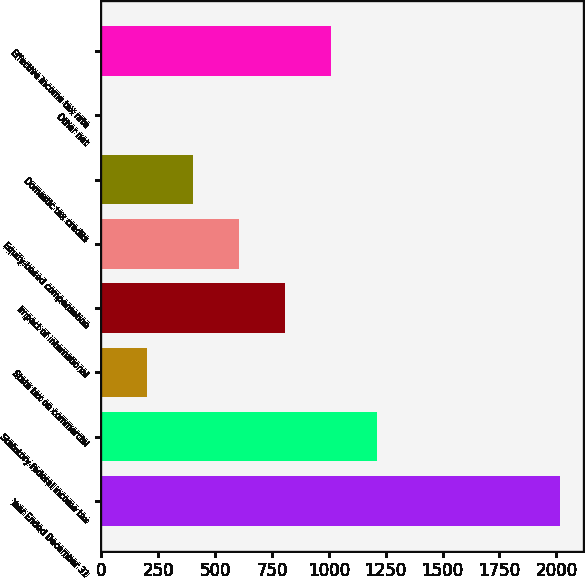Convert chart. <chart><loc_0><loc_0><loc_500><loc_500><bar_chart><fcel>Year Ended December 31<fcel>Statutory federal income tax<fcel>State tax on commercial<fcel>Impact of international<fcel>Equity-based compensation<fcel>Domestic tax credits<fcel>Other net<fcel>Effective income tax rate<nl><fcel>2016<fcel>1209.68<fcel>201.78<fcel>806.52<fcel>604.94<fcel>403.36<fcel>0.2<fcel>1008.1<nl></chart> 